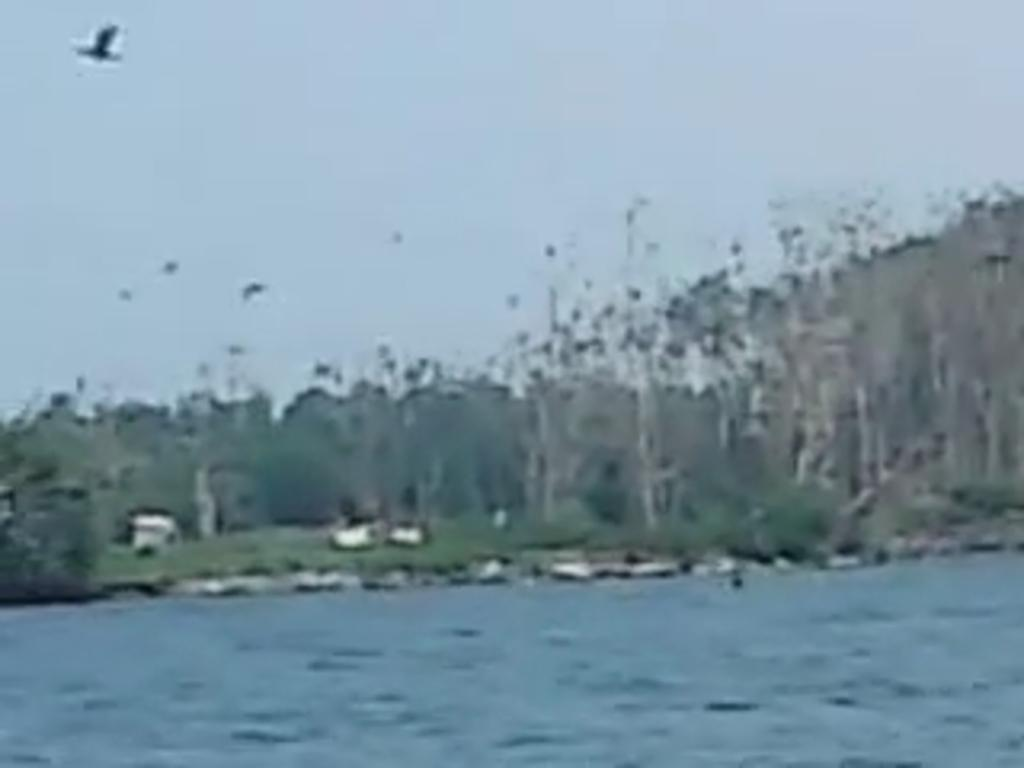What is the primary element present in the image? The image contains water. What type of vegetation can be seen in the image? There are trees in the image. What is the bird doing in the image? A bird is flying in the sky in the image. Where is the boy playing with the dog in the image? There is no boy or dog present in the image; it only features water, trees, and a flying bird. 